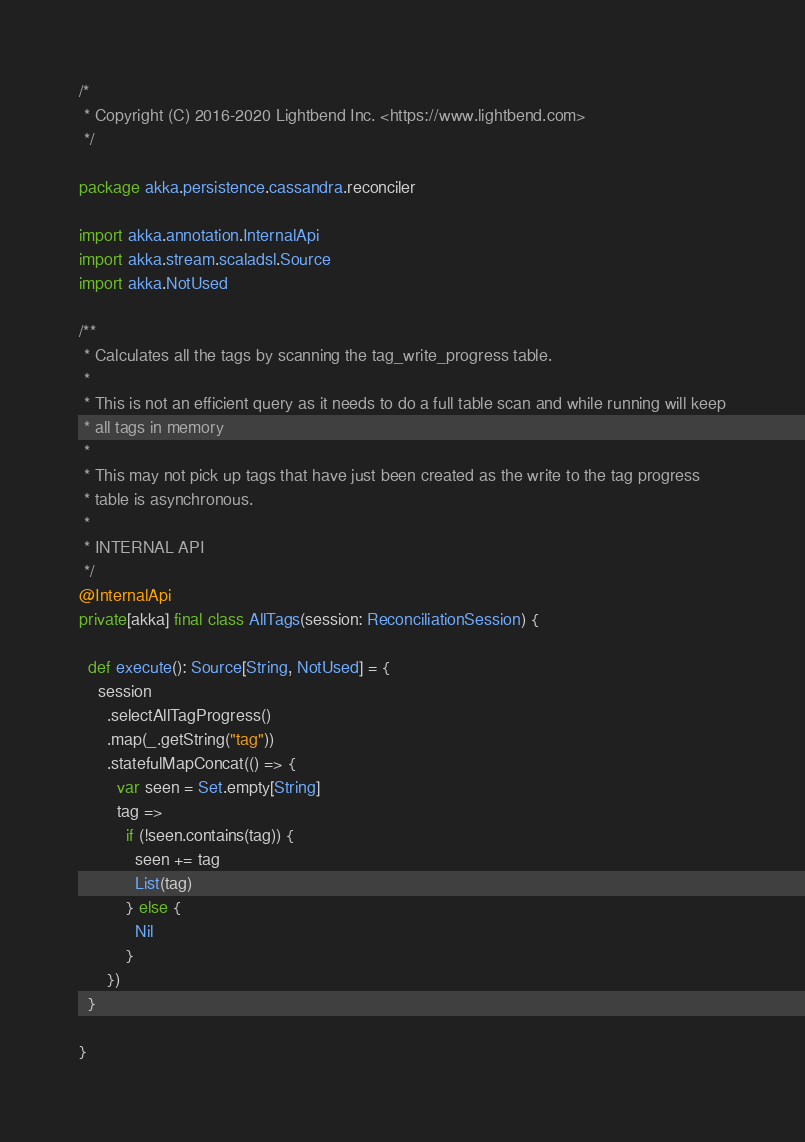Convert code to text. <code><loc_0><loc_0><loc_500><loc_500><_Scala_>/*
 * Copyright (C) 2016-2020 Lightbend Inc. <https://www.lightbend.com>
 */

package akka.persistence.cassandra.reconciler

import akka.annotation.InternalApi
import akka.stream.scaladsl.Source
import akka.NotUsed

/**
 * Calculates all the tags by scanning the tag_write_progress table.
 *
 * This is not an efficient query as it needs to do a full table scan and while running will keep
 * all tags in memory
 *
 * This may not pick up tags that have just been created as the write to the tag progress
 * table is asynchronous.
 *
 * INTERNAL API
 */
@InternalApi
private[akka] final class AllTags(session: ReconciliationSession) {

  def execute(): Source[String, NotUsed] = {
    session
      .selectAllTagProgress()
      .map(_.getString("tag"))
      .statefulMapConcat(() => {
        var seen = Set.empty[String]
        tag =>
          if (!seen.contains(tag)) {
            seen += tag
            List(tag)
          } else {
            Nil
          }
      })
  }

}
</code> 